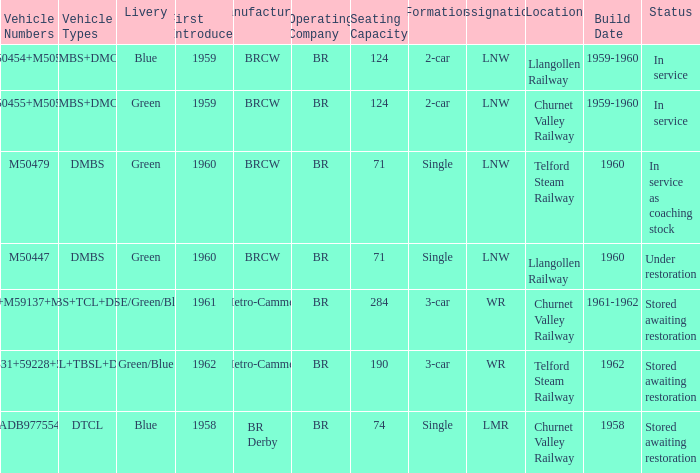What status is the vehicle types of dmbs+tcl+dmcl? Stored awaiting restoration. 